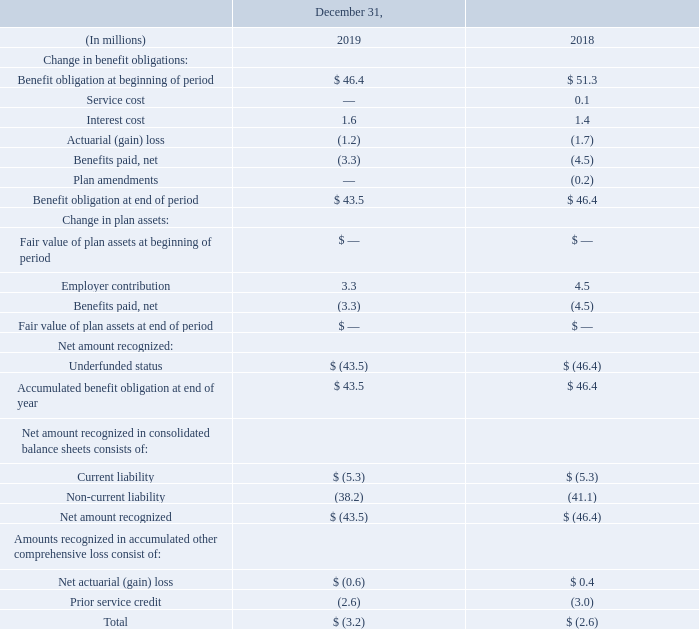Note 18 Other Post-Employment Benefits and Other Employee Benefit Plans
In addition to providing pension benefits, we maintain two Other Post-Employment Benefit Plans which provide a portion of healthcare, dental, vision and life insurance benefits for certain retired legacy employees. These plans are in the U.S. and Canada. Covered employees who retired on or after attaining age 55 and who had rendered at least 10 years of service were entitled to post-retirement healthcare, dental and life insurance benefits. These benefits are subject to deductibles, co-payment provisions and other limitations. The information below relates to these two plans.
Contributions made by us, net of Medicare Part D subsidies received in the U.S., are reported below as benefits paid. We may change the benefits at any time. The status of these plans, including a reconciliation of benefit obligations, a reconciliation of plan assets and the funded status of the plans, follows:
What employees are eligible for two Other Post-Employment Benefit Plans? Covered employees who retired on or after attaining age 55 and who had rendered at least 10 years of service. What years are included in the table? 2019, 2018. What does the table represent? Contributions made by us, net of medicare part d subsidies received in the u.s., are reported below as benefits paid. we may change the benefits at any time. the status of these plans, including a reconciliation of benefit obligations, a reconciliation of plan assets and the funded status of the plans. How much more Net actuarial gain is there in 2019 than 2018?
Answer scale should be: million. -0.6-0.4
Answer: -1. What is the difference between Benefit obligation at beginning of period for 2018 and 2019?
Answer scale should be: million. 51.3-46.4
Answer: 4.9. What is Benefit obligation at end of period expressed as a percentage of Benefit obligation at beginning of period for 2019?
Answer scale should be: percent. 43.5/46.4
Answer: 93.75. 